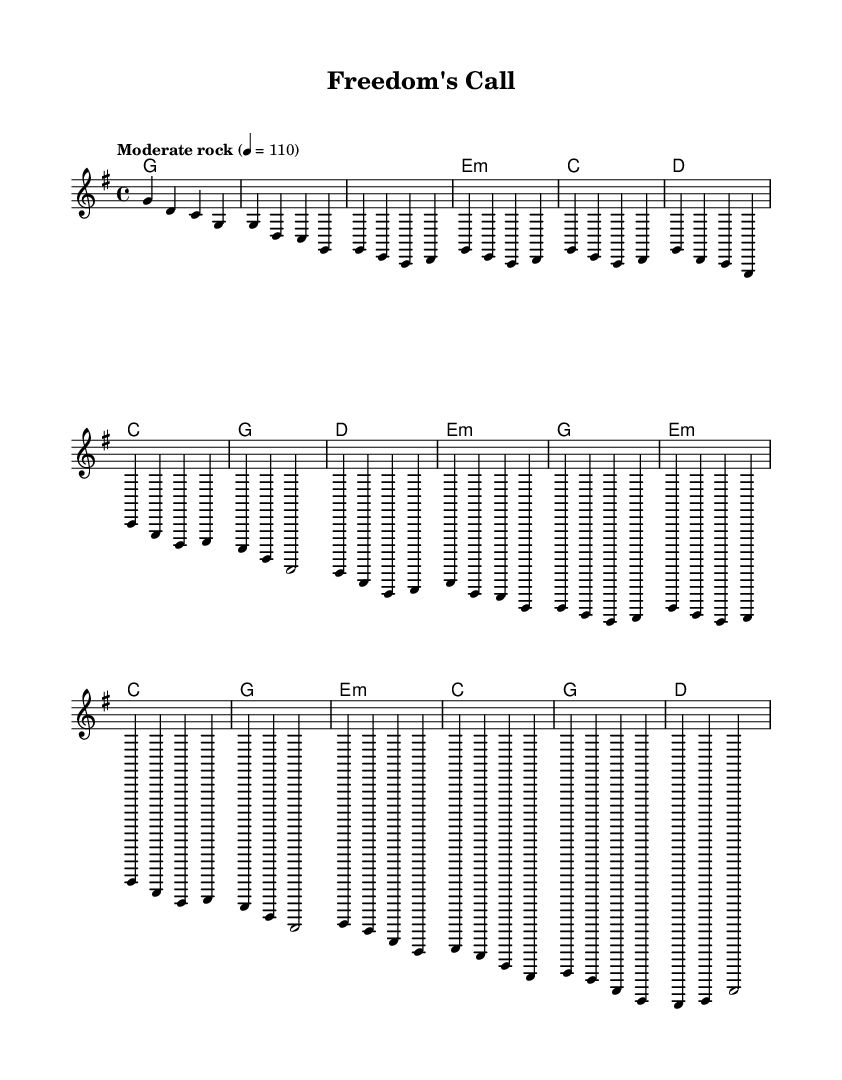What is the key signature of this music? The key signature is G major, which has one sharp (F#). This can be determined by looking at the key signature indication at the beginning of the staff.
Answer: G major What is the time signature of this piece? The time signature is 4/4, indicated at the beginning of the score. This means there are four beats per measure, and quarter notes receive one beat each.
Answer: 4/4 What is the tempo marking of the piece? The tempo marking is "Moderate rock" with a metronome marking of 110. This can be found in the header section of the score, indicating the speed at which the music should be performed.
Answer: Moderate rock 4 = 110 How many measures are there in the first verse? The first verse consists of four measures, as counted from the melody section where each measure is separated by a vertical line.
Answer: 4 What type of harmonic progression does the chorus follow? The chorus follows a I-V-vi-IV progression in the key of G major, where C (IV), G (I), D (V), and E minor (vi) chords are utilized. This understanding comes from analyzing the chords listed in the harmonies section against the melody notes.
Answer: I-V-vi-IV Identify the total number of bars in the bridge section. The bridge section contains four measures, identifiable in the score where each measure is clearly delineated. This can be counted from the harmonic and melody lines present in that section.
Answer: 4 What lyrical theme is suggested by the title "Freedom's Call"? The title implies a theme of liberty and possibly a critique of government overreach, as it resonates with Southern rock influences that often address social issues. This understanding is based on the context of the genre and the suggestive nature of the title.
Answer: Critique of government overreach 